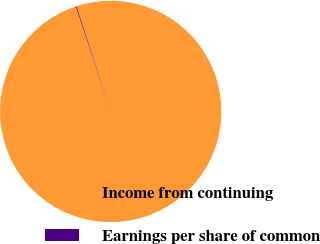<chart> <loc_0><loc_0><loc_500><loc_500><pie_chart><fcel>Income from continuing<fcel>Earnings per share of common<nl><fcel>99.88%<fcel>0.12%<nl></chart> 